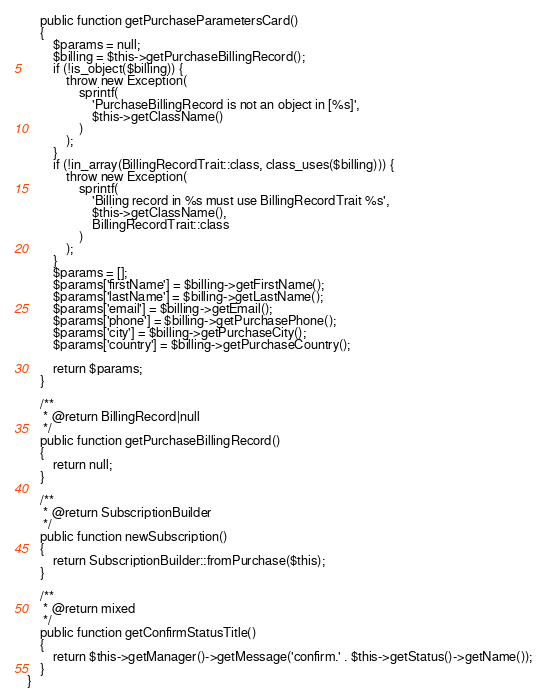<code> <loc_0><loc_0><loc_500><loc_500><_PHP_>    public function getPurchaseParametersCard()
    {
        $params = null;
        $billing = $this->getPurchaseBillingRecord();
        if (!is_object($billing)) {
            throw new Exception(
                sprintf(
                    'PurchaseBillingRecord is not an object in [%s]',
                    $this->getClassName()
                )
            );
        }
        if (!in_array(BillingRecordTrait::class, class_uses($billing))) {
            throw new Exception(
                sprintf(
                    'Billing record in %s must use BillingRecordTrait %s',
                    $this->getClassName(),
                    BillingRecordTrait::class
                )
            );
        }
        $params = [];
        $params['firstName'] = $billing->getFirstName();
        $params['lastName'] = $billing->getLastName();
        $params['email'] = $billing->getEmail();
        $params['phone'] = $billing->getPurchasePhone();
        $params['city'] = $billing->getPurchaseCity();
        $params['country'] = $billing->getPurchaseCountry();

        return $params;
    }

    /**
     * @return BillingRecord|null
     */
    public function getPurchaseBillingRecord()
    {
        return null;
    }

    /**
     * @return SubscriptionBuilder
     */
    public function newSubscription()
    {
        return SubscriptionBuilder::fromPurchase($this);
    }

    /**
     * @return mixed
     */
    public function getConfirmStatusTitle()
    {
        return $this->getManager()->getMessage('confirm.' . $this->getStatus()->getName());
    }
}
</code> 